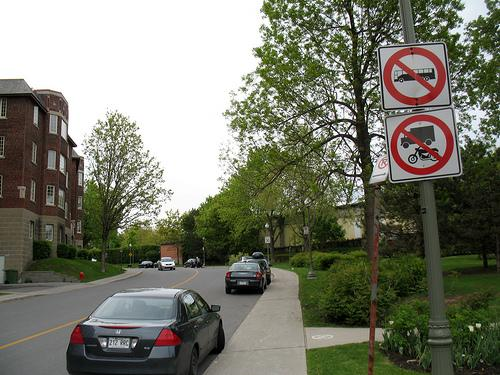How many signs have a diagonal line through them?

Choices:
A) four
B) five
C) seven
D) two two 